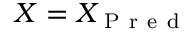<formula> <loc_0><loc_0><loc_500><loc_500>X = X _ { P r e d }</formula> 